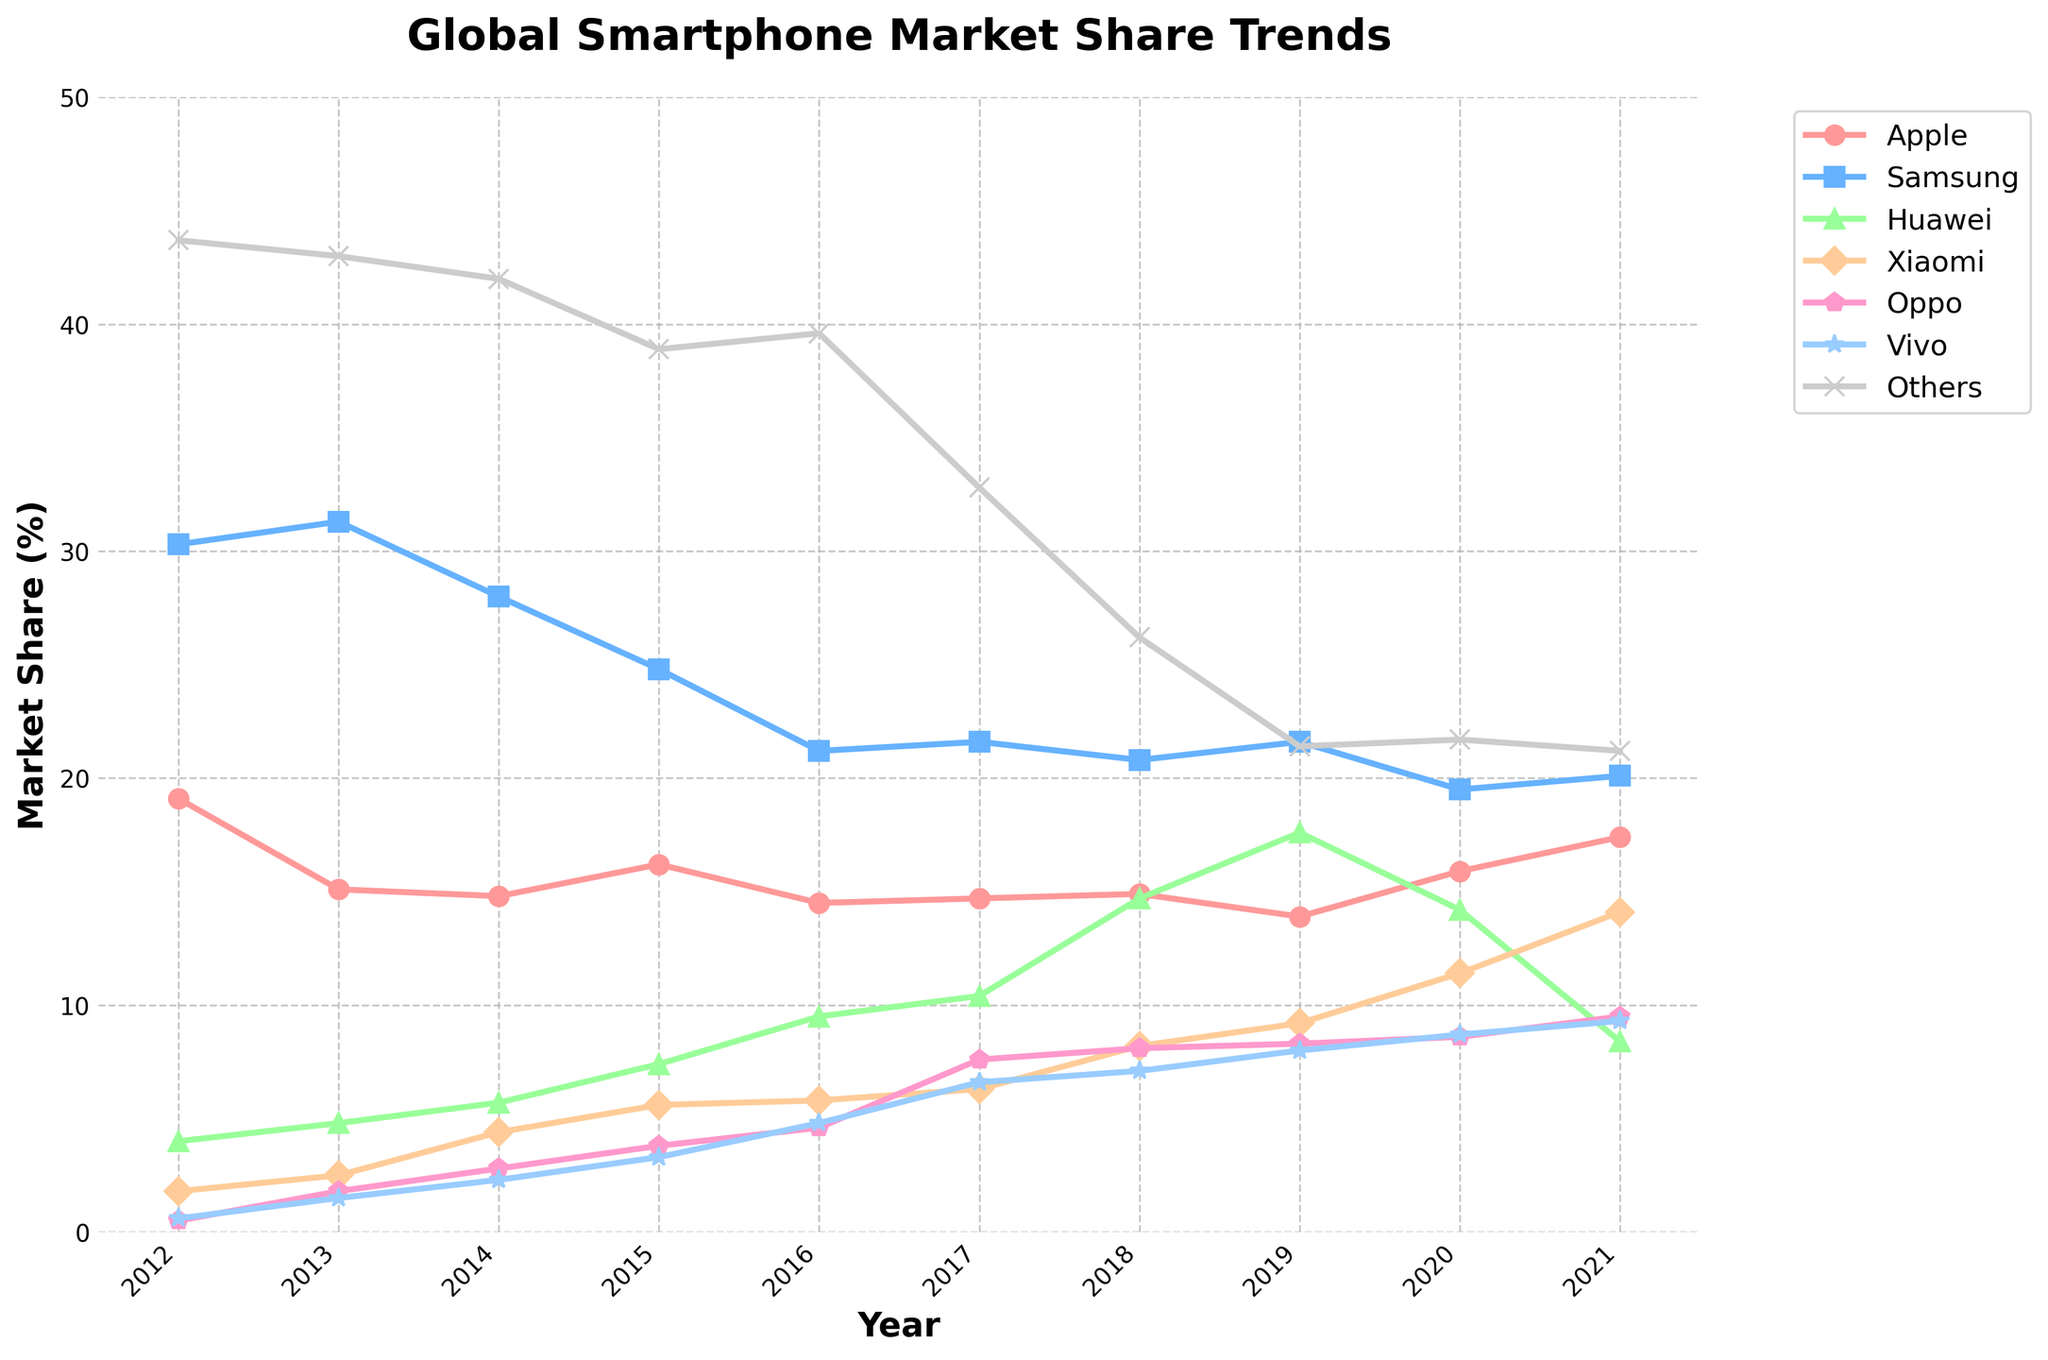What was the market share trend of Apple from 2012 to 2021? Let's look at the line for Apple. It starts at around 19.1% in 2012, drops to around 14.5% in 2016, and then rises to approximately 17.4% by 2021. So, the trend started with a decline followed by a rise.
Answer: Decline then rise Which manufacturer had the highest market share in 2019? We examine the markers for the year 2019. Samsung's market share is around 21.6%, while Huawei's market share is even higher at around 17.6%. Comparing all the data points, Huawei has the highest market share.
Answer: Huawei What's the difference in market share between Oppo and Vivo in 2021? For 2021, the market share for Oppo is approximately 9.5% and for Vivo, it is around 9.3%. Subtracting Vivo's market share from Oppo's, the difference is 0.2%.
Answer: 0.2% Which manufacturer had the most consistent market share over the decade? Consistent market share implies less fluctuation. By visually checking the trend lines, Apple’s line shows the least variation, hovering mostly around a few percentage points.
Answer: Apple What is the sum of the market shares of Xiaomi and Huawei in 2020? In 2020, the market shares are 11.4% for Xiaomi and 14.2% for Huawei. Adding these values: 11.4% + 14.2% = 25.6%.
Answer: 25.6% Did Samsung or Apple have a greater maximum market share during this decade? Samsung’s highest point is over 30% (31.3% in 2013), while Apple’s highest point is just over 19% (19.1% in 2012). Comparing these two, Samsung had the greater maximum market share.
Answer: Samsung How did the market share for 'Others' change from 2012 to 2021? The 'Others' category starts at 43.7% in 2012 and decreases to 21.2% by 2021. Therefore, there is a significant decline.
Answer: Decline Which manufacturer shows a significant rise during the period and ends up with a top-four market share in 2021? Examining the lines, Xiaomi shows an increase from 1.8% in 2012 to 14.1% in 2021, ranking within the top four by the end of the decade.
Answer: Xiaomi What’s the visual change in market share trend for Huawei between 2019 and 2021? The line for Huawei peaks at 17.6% in 2019 but then sharply falls to 8.4% by 2021. The visual change is a steep downward slope.
Answer: Sharp decline 